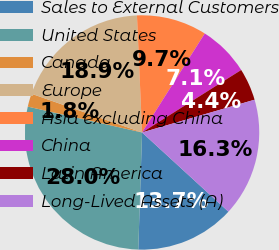Convert chart to OTSL. <chart><loc_0><loc_0><loc_500><loc_500><pie_chart><fcel>Sales to External Customers<fcel>United States<fcel>Canada<fcel>Europe<fcel>Asia excluding China<fcel>China<fcel>Latin America<fcel>Long-Lived Assets (A)<nl><fcel>13.7%<fcel>28.02%<fcel>1.82%<fcel>18.94%<fcel>9.68%<fcel>7.06%<fcel>4.44%<fcel>16.32%<nl></chart> 